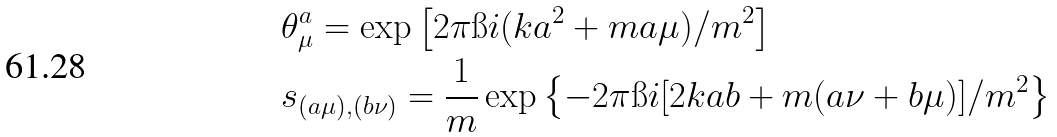Convert formula to latex. <formula><loc_0><loc_0><loc_500><loc_500>& \theta ^ { a } _ { \mu } = \exp \left [ 2 \pi \i i ( k a ^ { 2 } + m a \mu ) / m ^ { 2 } \right ] \\ & s _ { ( a \mu ) , ( b \nu ) } = \frac { 1 } { m } \exp \left \{ - 2 \pi \i i [ 2 k a b + m ( a \nu + b \mu ) ] / m ^ { 2 } \right \}</formula> 